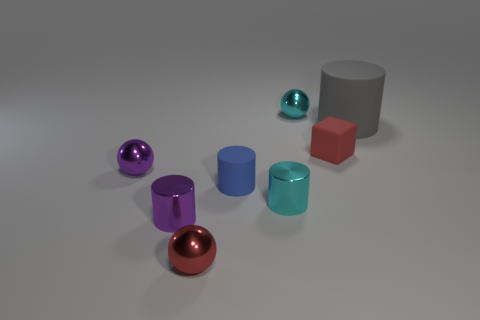Add 1 rubber cylinders. How many objects exist? 9 Subtract all cubes. How many objects are left? 7 Subtract all small metallic cylinders. Subtract all tiny matte cylinders. How many objects are left? 5 Add 8 blue cylinders. How many blue cylinders are left? 9 Add 5 big red shiny objects. How many big red shiny objects exist? 5 Subtract 0 gray blocks. How many objects are left? 8 